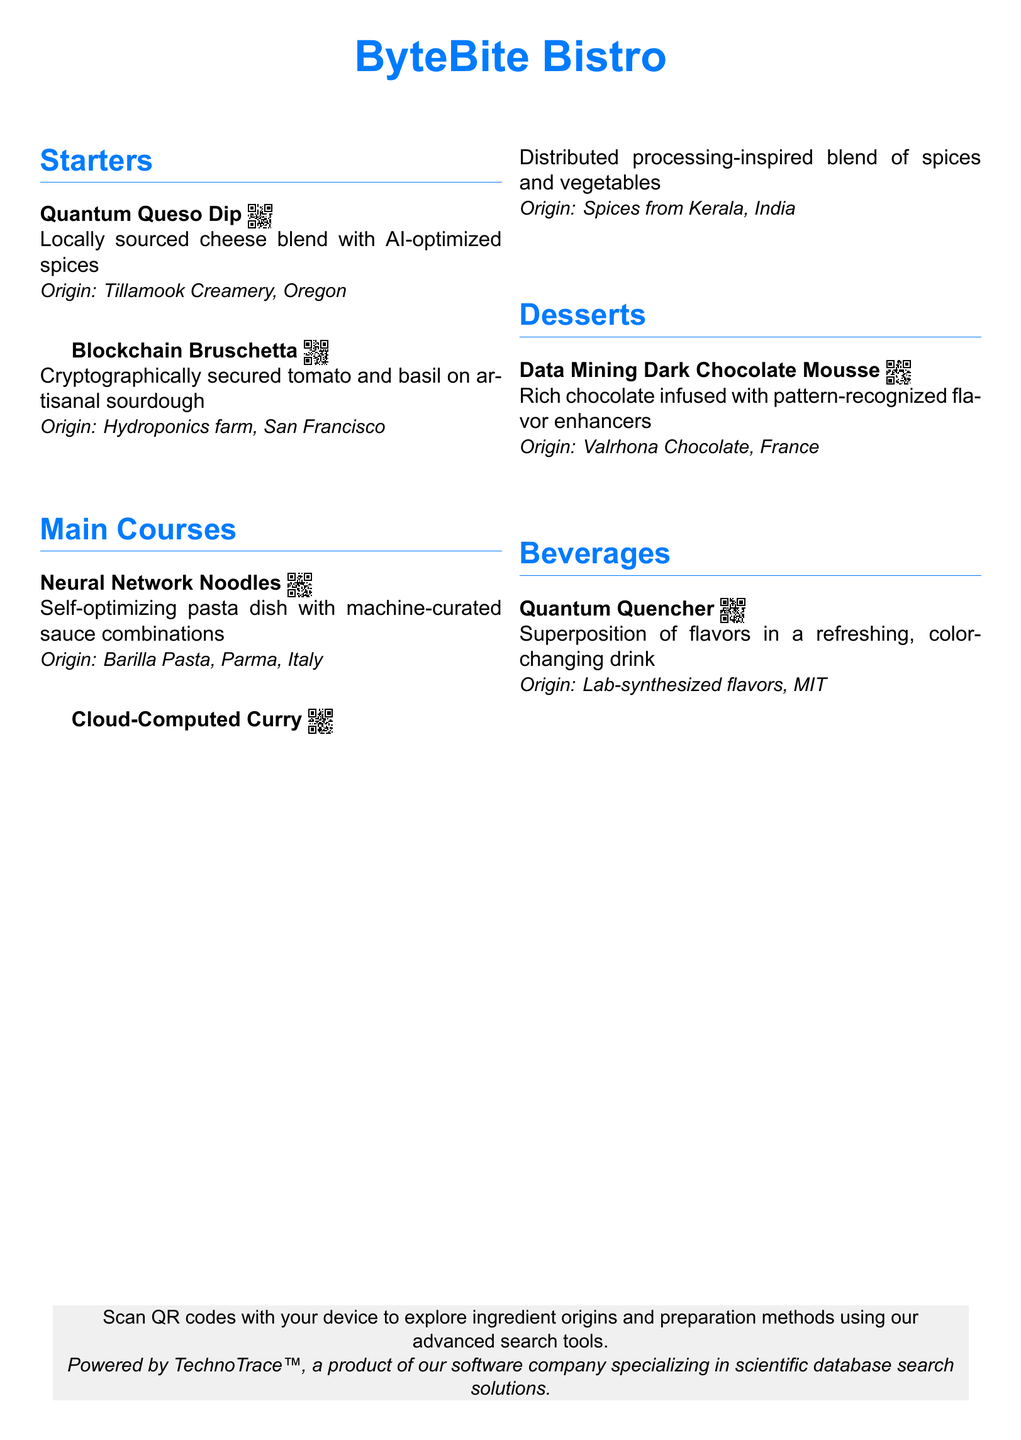What is the name of the restaurant? The restaurant is called ByteBite Bistro, which is the main title presented at the top of the document.
Answer: ByteBite Bistro How many sections are in the menu? The menu has four main sections listed: Starters, Main Courses, Desserts, and Beverages.
Answer: 4 What ingredient is used in the Quantum Queso Dip? The Quantum Queso Dip features a locally sourced cheese blend, which is specified in the description of the dish.
Answer: Cheese blend Where is the origin of the Data Mining Dark Chocolate Mousse? The origin of the Data Mining Dark Chocolate Mousse is specified in the document as Valrhona Chocolate, France.
Answer: Valrhona Chocolate, France What flavor technique is used in the Quantum Quencher? The Quantum Quencher employs a superposition of flavors, as noted in the drink's description.
Answer: Superposition Which dish is inspired by distributed processing? The Cloud-Computed Curry is inspired by distributed processing, as mentioned in the description.
Answer: Cloud-Computed Curry What QR code is associated with the Neural Network Noodles? The QR code associated with the Neural Network Noodles is labeled as QR003 in the document.
Answer: QR003 What type of drink is the Quantum Quencher? The Quantum Quencher is described as a refreshing, color-changing drink according to the menu.
Answer: Refreshing, color-changing drink Which item uses AI-optimized spices? The Quantum Queso Dip is the item that uses AI-optimized spices as outlined in its description.
Answer: Quantum Queso Dip 